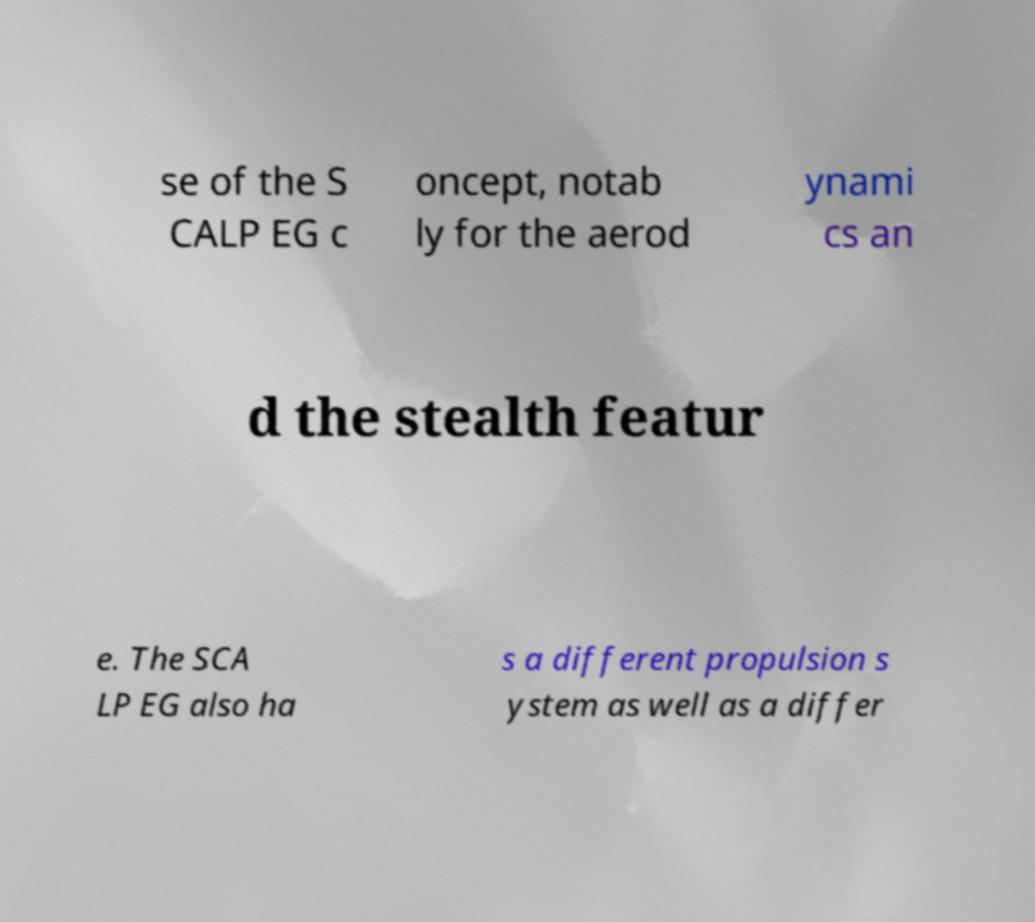Could you assist in decoding the text presented in this image and type it out clearly? se of the S CALP EG c oncept, notab ly for the aerod ynami cs an d the stealth featur e. The SCA LP EG also ha s a different propulsion s ystem as well as a differ 